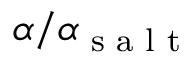<formula> <loc_0><loc_0><loc_500><loc_500>\alpha / \alpha _ { s a l t }</formula> 